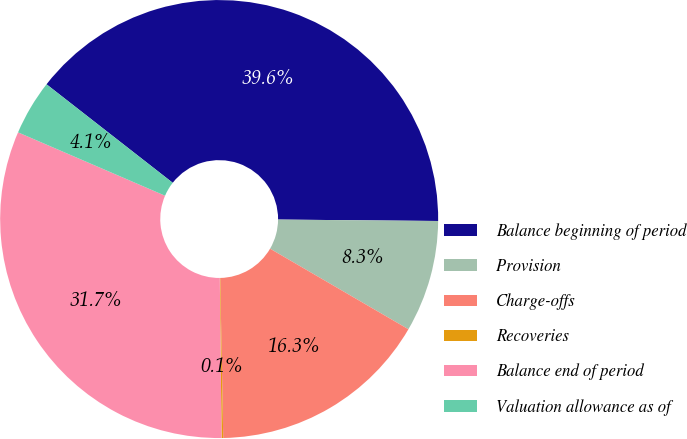Convert chart to OTSL. <chart><loc_0><loc_0><loc_500><loc_500><pie_chart><fcel>Balance beginning of period<fcel>Provision<fcel>Charge-offs<fcel>Recoveries<fcel>Balance end of period<fcel>Valuation allowance as of<nl><fcel>39.59%<fcel>8.25%<fcel>16.31%<fcel>0.12%<fcel>31.65%<fcel>4.07%<nl></chart> 